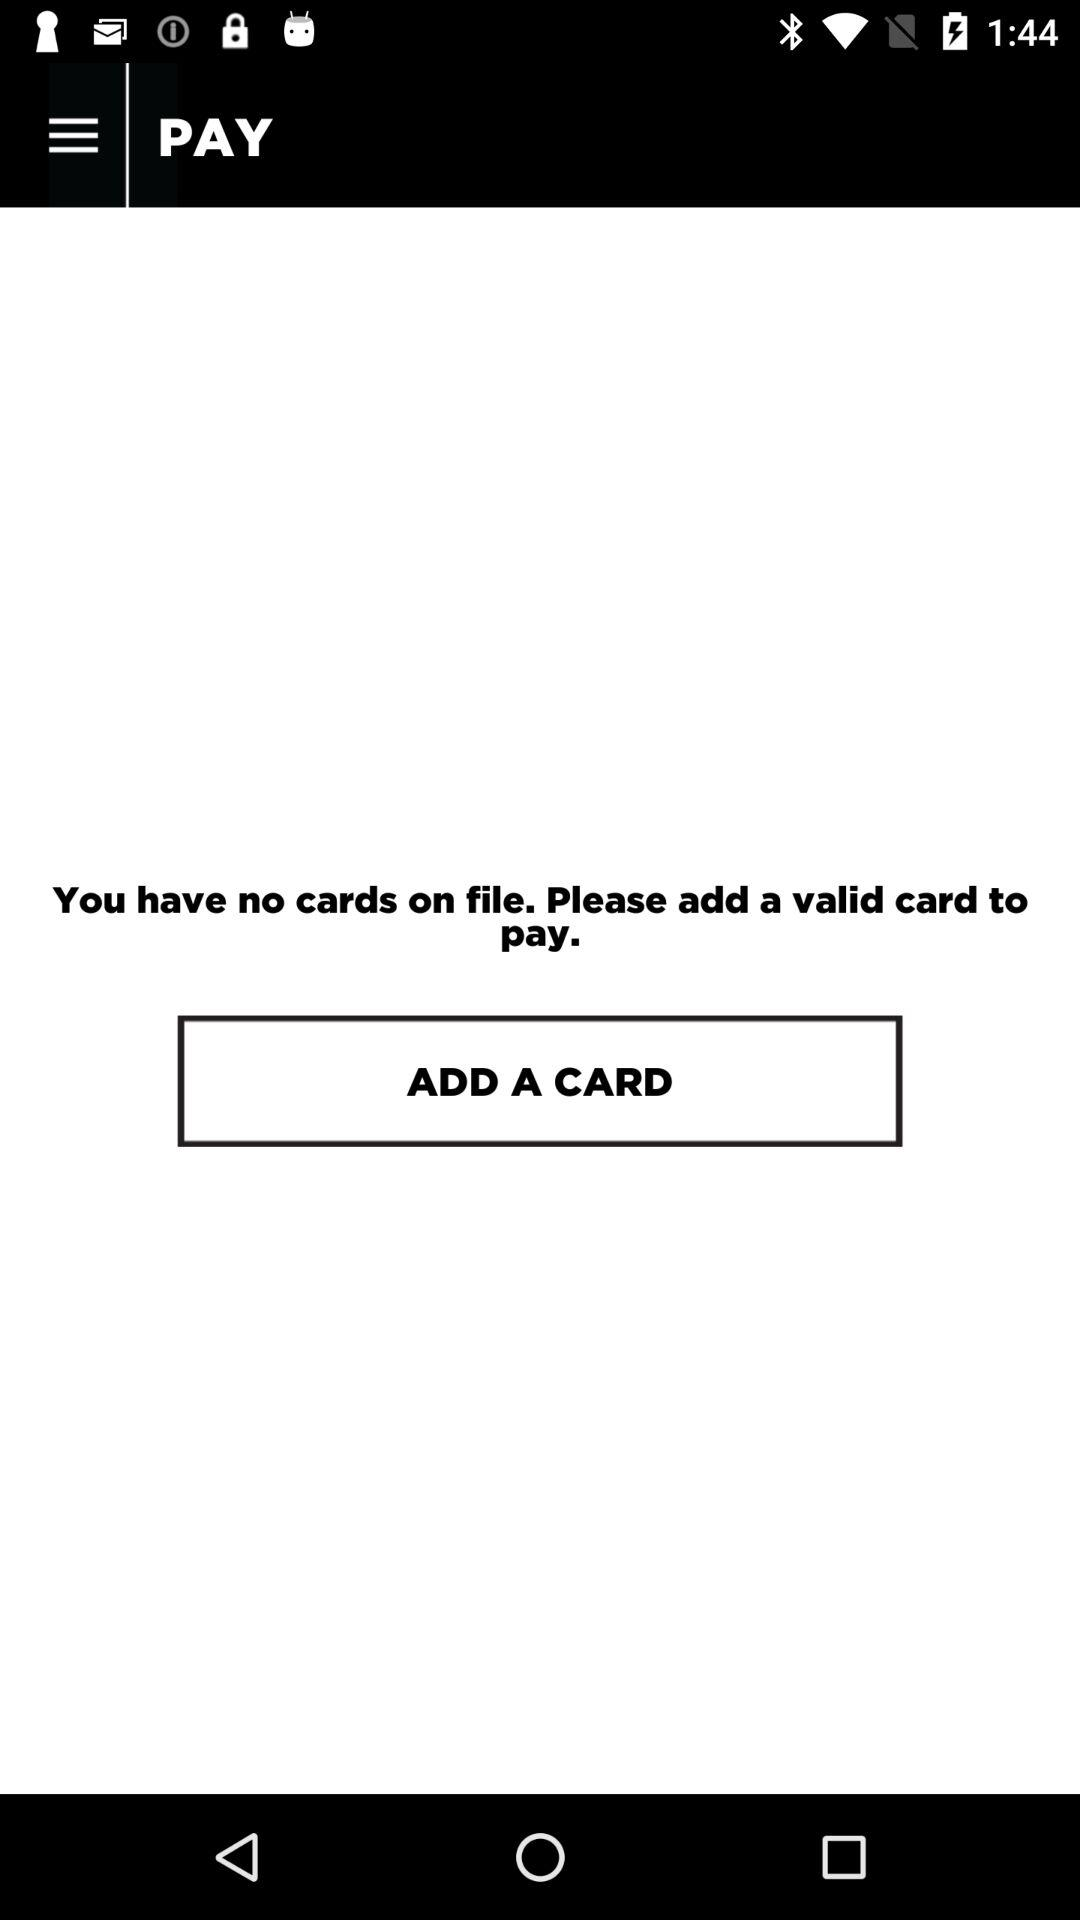What is the name of the application? The name of the application is "PAY". 